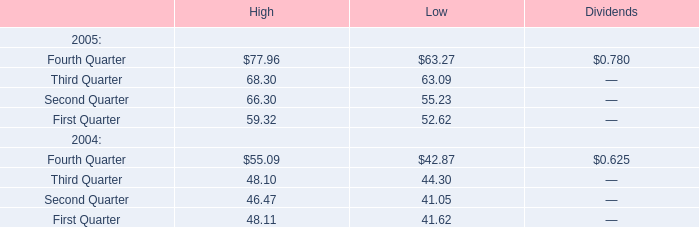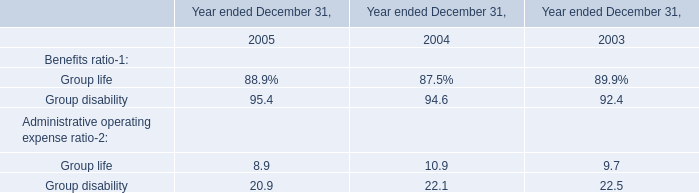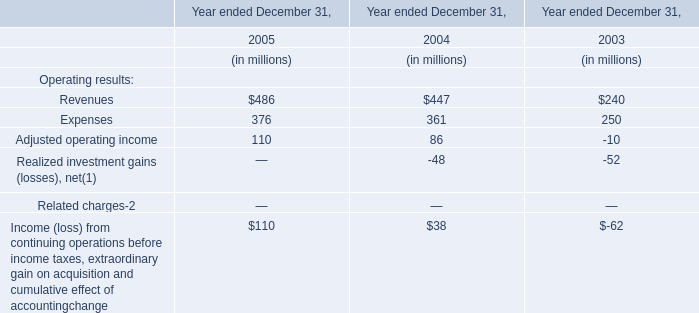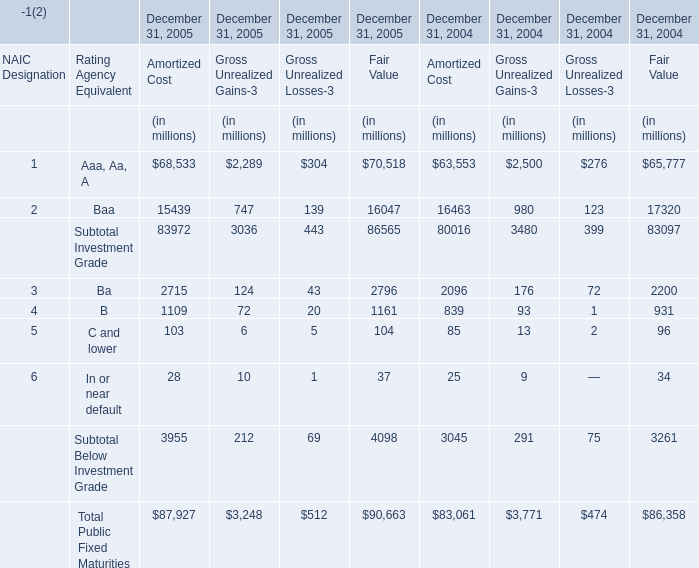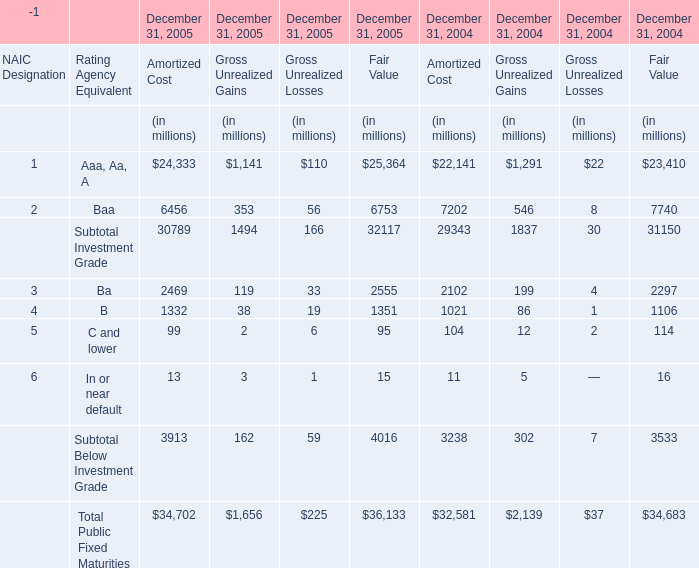Which year is Ba for Fair Value greater than 30 ? 
Answer: 2005. 